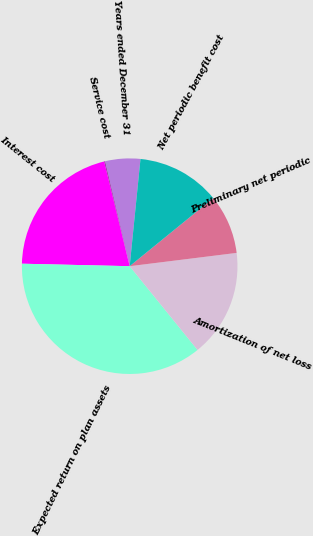<chart> <loc_0><loc_0><loc_500><loc_500><pie_chart><fcel>Years ended December 31<fcel>Service cost<fcel>Interest cost<fcel>Expected return on plan assets<fcel>Amortization of net loss<fcel>Preliminary net periodic<fcel>Net periodic benefit cost<nl><fcel>5.3%<fcel>0.1%<fcel>20.83%<fcel>36.2%<fcel>16.13%<fcel>8.91%<fcel>12.52%<nl></chart> 